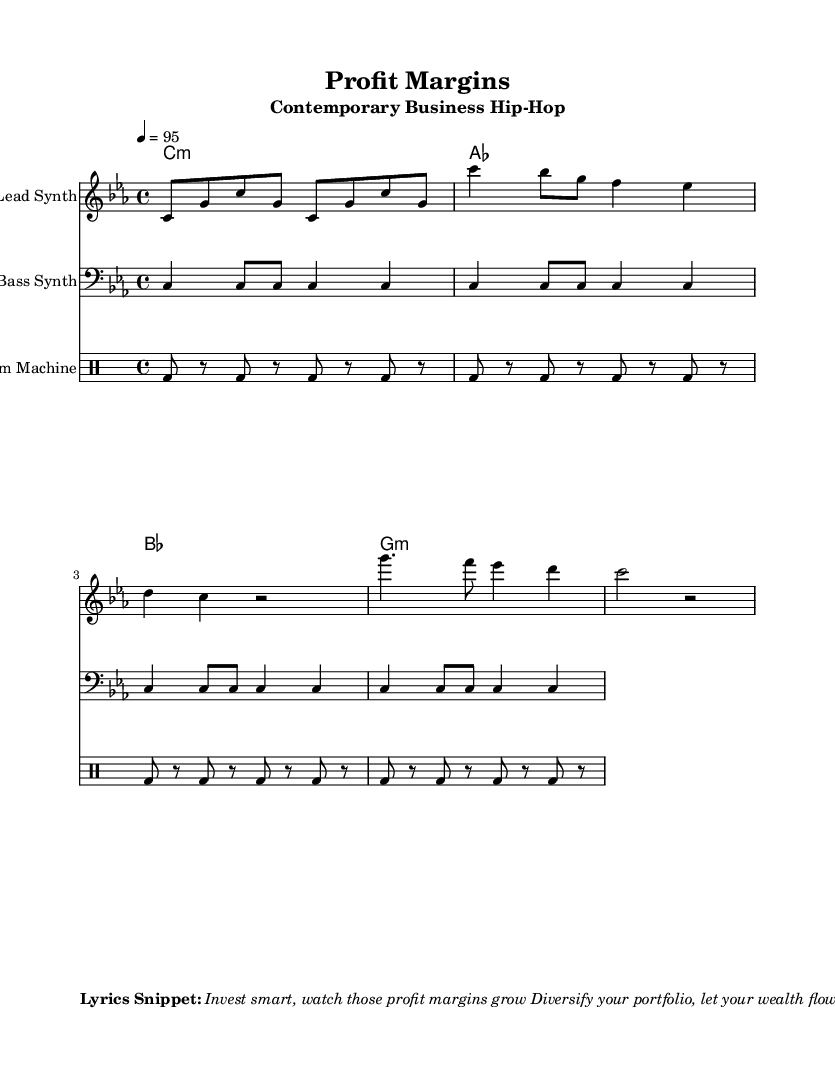What is the key signature of this music? The key signature is C minor, which includes the notes B♭, E♭, and A♭. This can be determined by looking at the overall structure of the piece which indicates C minor through its scale notes and harmonies.
Answer: C minor What is the time signature of this piece? The time signature is 4/4, meaning there are four beats in each measure, and the quarter note receives one beat. This can be identified at the beginning of the sheet music where the 4/4 is indicated after the key signature.
Answer: 4/4 What is the tempo marking for this piece? The tempo marking is 95 beats per minute, which indicates the speed at which the piece should be played. This is specified in the tempo directive at the beginning of the score.
Answer: 95 How many measures are in the lead synth part? The lead synth part contains 8 measures, which can be counted by identifying the number of distinct sections within the notation where the rhythmic patterns repeat or change.
Answer: 8 What chords are used in the piano chords section? The chords used are C minor, A♭ major, B♭ major, and G minor. This can be identified from the chord symbols written above the staff in the chord mode section.
Answer: C minor, A♭ major, B♭ major, G minor What is the primary theme of the lyrics snippet? The primary theme revolves around financial wisdom and wealth accumulation strategies. By analyzing the provided lyrics snippet, it emphasizes investing smartly and diversifying portfolios, suggesting a focus on financial growth.
Answer: Financial wisdom 